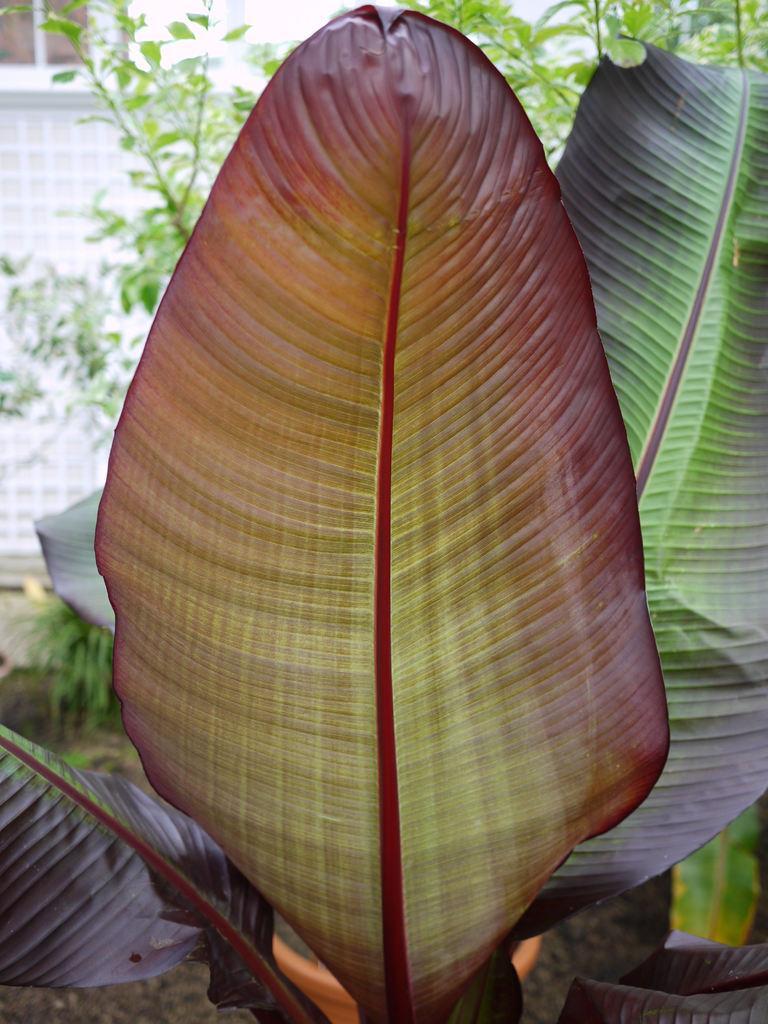How would you summarize this image in a sentence or two? In this picture we can see a plant in the front, in the background there is a wall and a window, we can see a tree in the middle. 